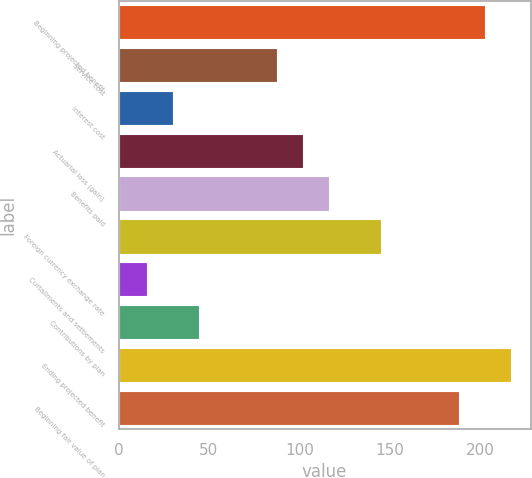<chart> <loc_0><loc_0><loc_500><loc_500><bar_chart><fcel>Beginning projected benefit<fcel>Service cost<fcel>Interest cost<fcel>Actuarial loss (gain)<fcel>Benefits paid<fcel>Foreign currency exchange rate<fcel>Curtailments and settlements<fcel>Contributions by plan<fcel>Ending projected benefit<fcel>Beginning fair value of plan<nl><fcel>202.76<fcel>87.64<fcel>30.08<fcel>102.03<fcel>116.42<fcel>145.2<fcel>15.69<fcel>44.47<fcel>217.15<fcel>188.37<nl></chart> 